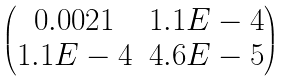<formula> <loc_0><loc_0><loc_500><loc_500>\begin{pmatrix} 0 . 0 0 2 1 & 1 . 1 E - 4 \\ 1 . 1 E - 4 & 4 . 6 E - 5 \end{pmatrix}</formula> 